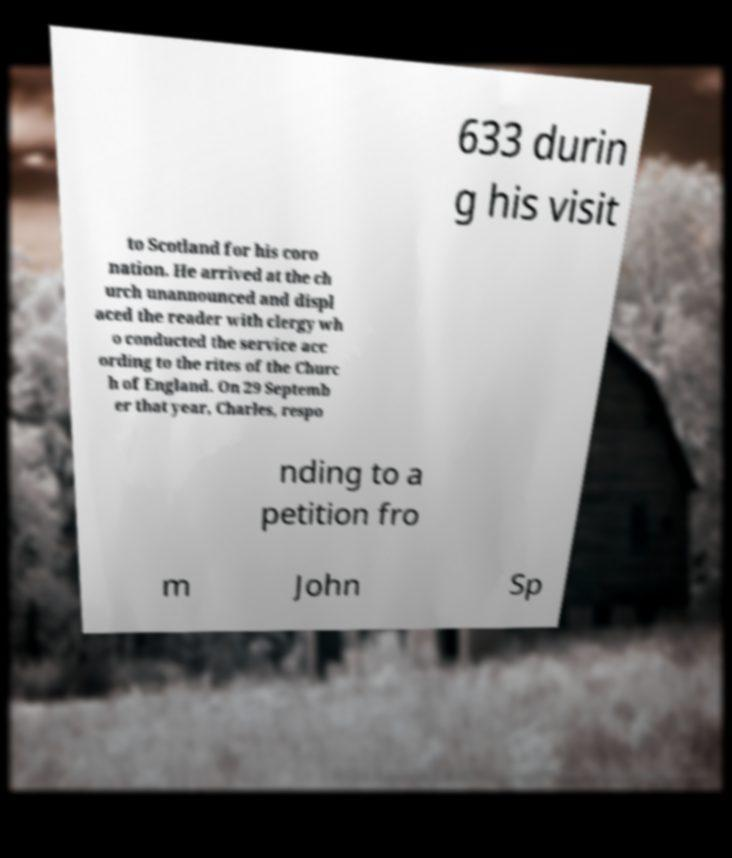What messages or text are displayed in this image? I need them in a readable, typed format. 633 durin g his visit to Scotland for his coro nation. He arrived at the ch urch unannounced and displ aced the reader with clergy wh o conducted the service acc ording to the rites of the Churc h of England. On 29 Septemb er that year, Charles, respo nding to a petition fro m John Sp 